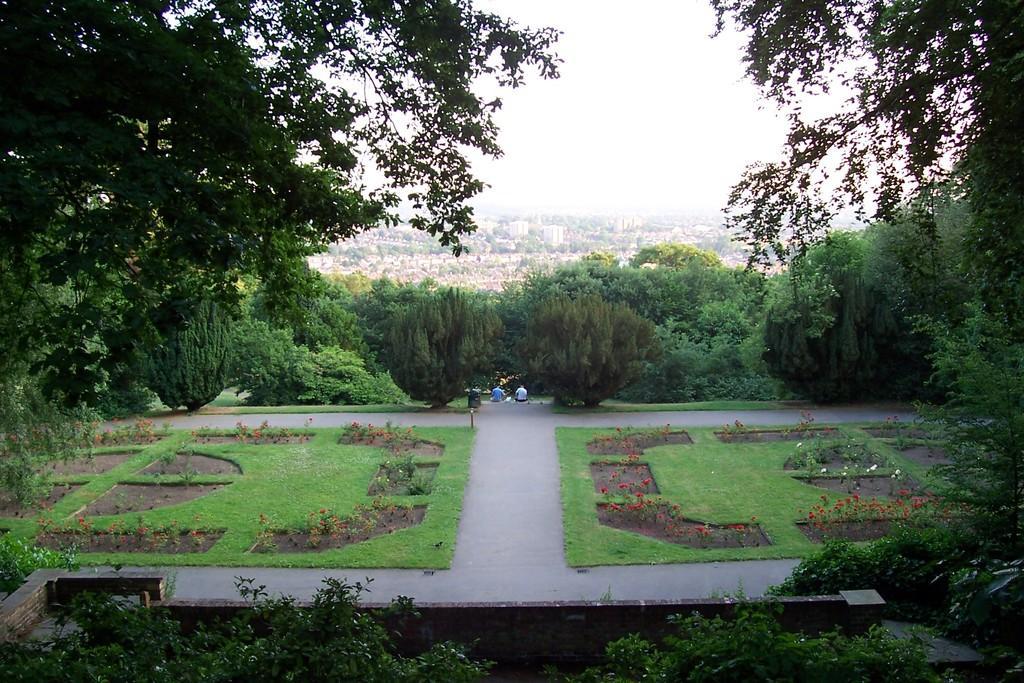In one or two sentences, can you explain what this image depicts? This image looks like a garden. At the bottom, we can see small plants and green grass on the ground. In the background, there are many trees and buildings. At the top, there is sky. 